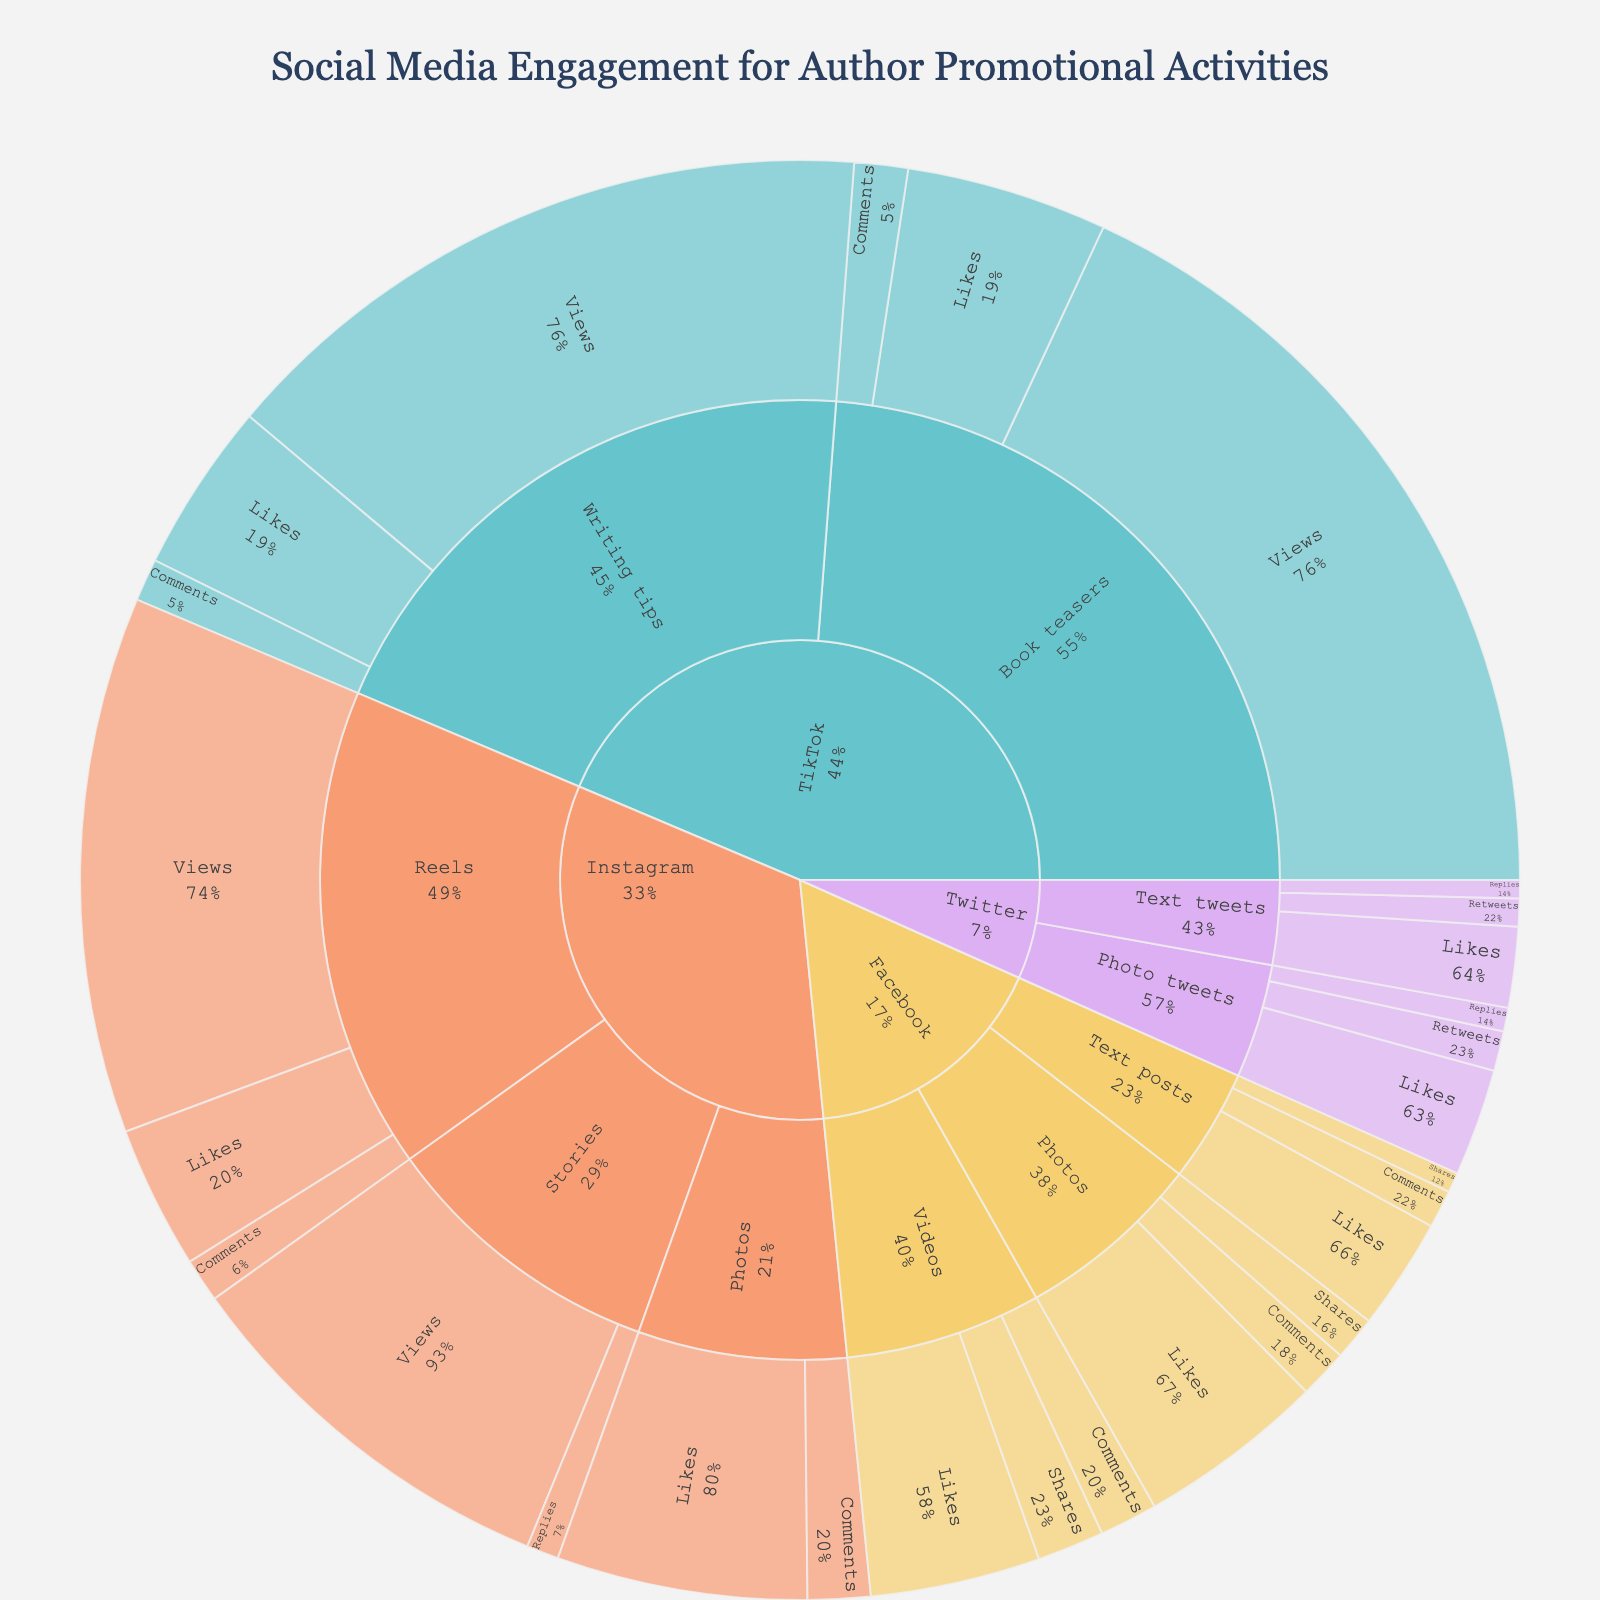what is the title of the plot? The title is found at the top of the plot and usually provides a summary of what the plot represents. In this case, the title of the plot is "Social Media Engagement for Author Promotional Activities."
Answer: Social Media Engagement for Author Promotional Activities Which platform has the highest engagement for videos? Look for the segment labeled 'Videos' under each platform and observe the section sizes corresponding to engagement metrics (Likes, Comments, Shares). The largest segment signifies the highest engagement. For videos, Facebook has the highest engagement since its sections are appreciably large.
Answer: Facebook How many engagement categories are there for Instagram? Instagram has categories for 'Photos,' 'Stories,' and 'Reels.' Each of these has subsections indicating types of engagement (Likes, Comments, Views, Replies). By counting these sections, we determine there are three main engagement categories.
Answer: 3 Which has more likes: Instagram Photos or TikTok Writing tips? Locate both sections—Instagram Photos (Likes) and TikTok Writing tips (Likes). Compare the values provided in the segments. Instagram Photos have 5600 Likes, whereas TikTok Writing tips have 3800 Likes. Thus, Instagram Photos have more likes.
Answer: Instagram Photos What is the total number of likes for Facebook content types? Add up the Likes for each content type within Facebook: Text posts (2500), Photos (4200), and Videos (3800). The calculation is 2500 + 4200 + 3800, resulting in a total of 10500 Likes.
Answer: 10500 Which platform has the highest number of views? Look for the 'Views' segment under each platform. TikTok's 'Book teasers' have the highest number of views, which is 18000.
Answer: TikTok Among the platforms, which one has the least engagement for text posts? Examine the 'Text posts' sections under each platform and compare their engagement values (Likes, Comments, Shares or Replies). Twitter has the least engagement in Text posts compared to Facebook.
Answer: Twitter What's the most common type of engagement metric across all platforms? Review all the segments to observe which engagement metrics frequently appear across all platforms. Likes appear in Facebook, Instagram, TikTok—making it the most common type of engagement metric.
Answer: Likes What is the total engagement for TikTok's Book teasers? Sum the engagement metrics (Views, Likes, Comments) for TikTok's Book teasers: 18000 Views + 4500 Likes + 1200 Comments = 23700 total engagements.
Answer: 23700 How do Facebook and Instagram compare in terms of the total number of comments? Calculate the comments for Facebook content (Text posts: 850, Photos: 1100, Videos: 1300) and Instagram content (Photos: 1400, Reels: 980). Facebook total comments = 850 + 1100 + 1300 = 3250; Instagram total comments = 1400 + 980 = 2380. Facebook has more comments compared to Instagram.
Answer: Facebook 